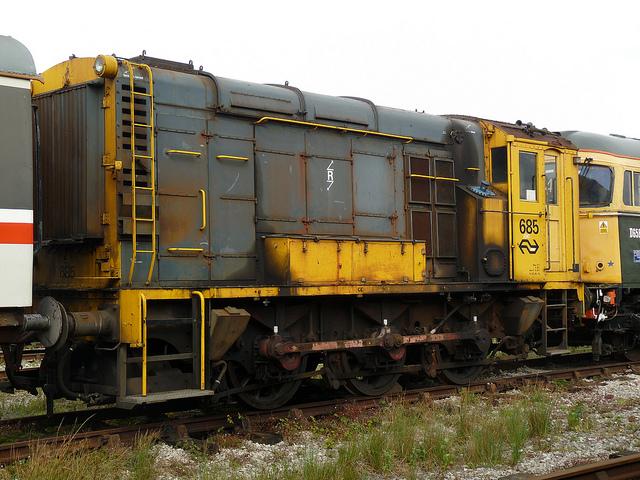Is there snow on the ground?
Quick response, please. No. Is this a passenger train?
Answer briefly. No. What # is the train?
Give a very brief answer. 685. 